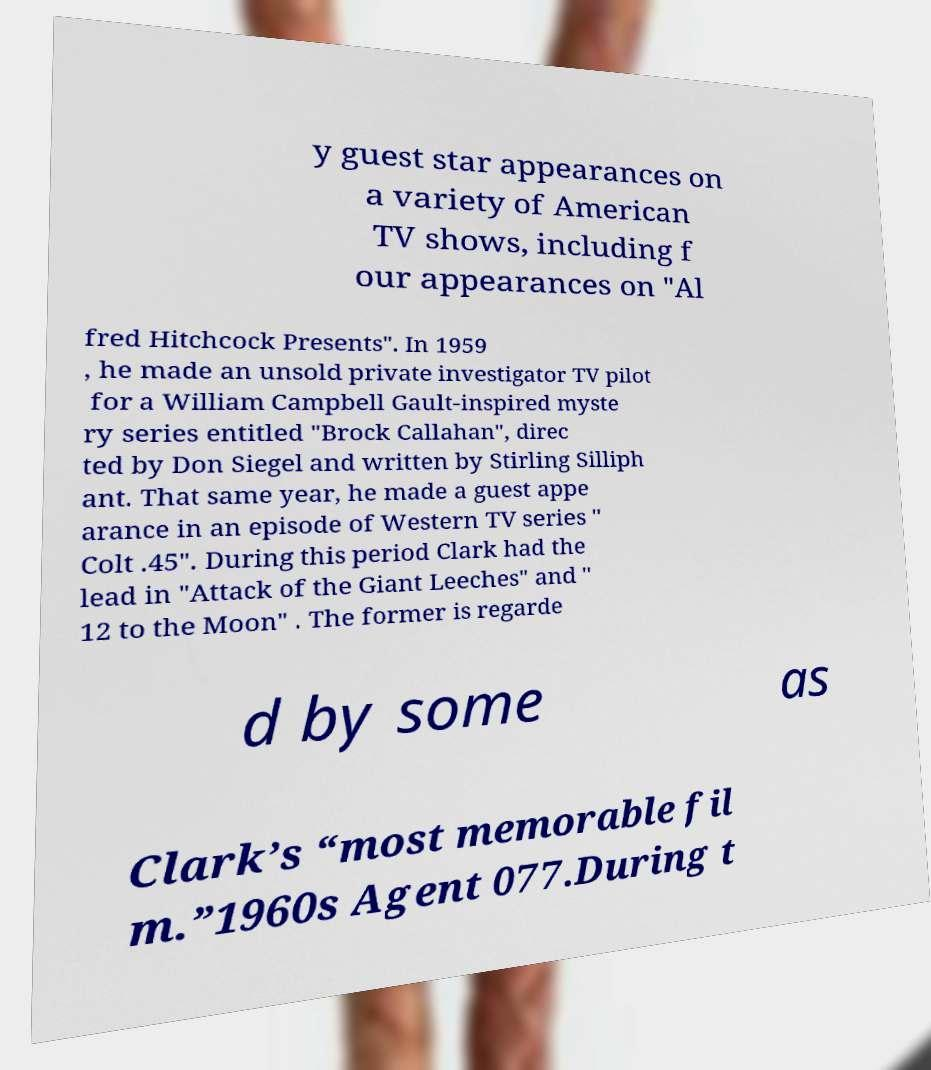For documentation purposes, I need the text within this image transcribed. Could you provide that? y guest star appearances on a variety of American TV shows, including f our appearances on "Al fred Hitchcock Presents". In 1959 , he made an unsold private investigator TV pilot for a William Campbell Gault-inspired myste ry series entitled "Brock Callahan", direc ted by Don Siegel and written by Stirling Silliph ant. That same year, he made a guest appe arance in an episode of Western TV series " Colt .45". During this period Clark had the lead in "Attack of the Giant Leeches" and " 12 to the Moon" . The former is regarde d by some as Clark’s “most memorable fil m.”1960s Agent 077.During t 